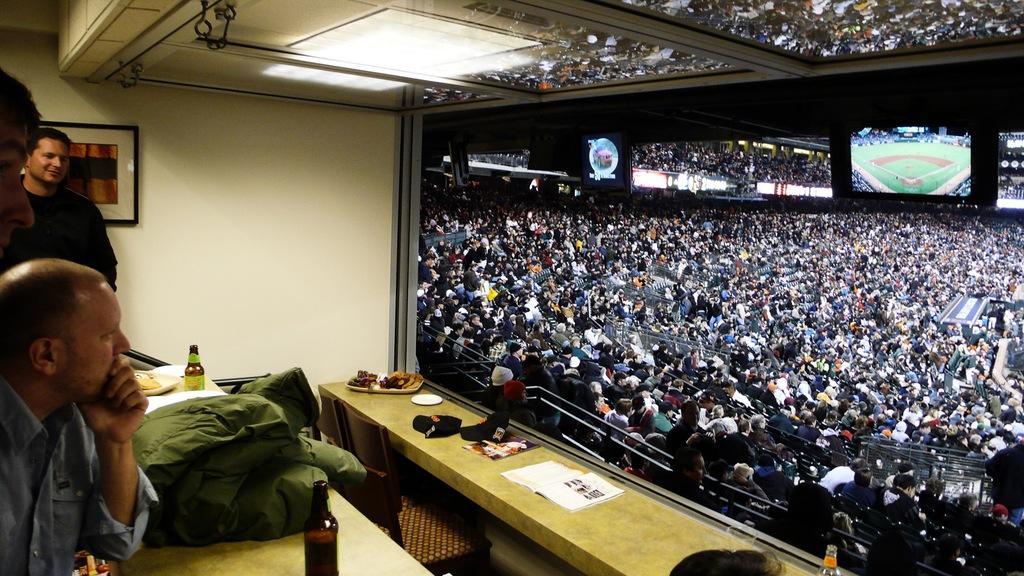Could you give a brief overview of what you see in this image? On the left side of the image there are people. In front of them there are tables. On top of the tables there are wine bottles, books and there are a few objects. There are chairs. On top of the image there are lights. There is a wall with the photo frame on it. There is a glass window through which we can see people sitting in the stadium. In the background of the image there is sky. 